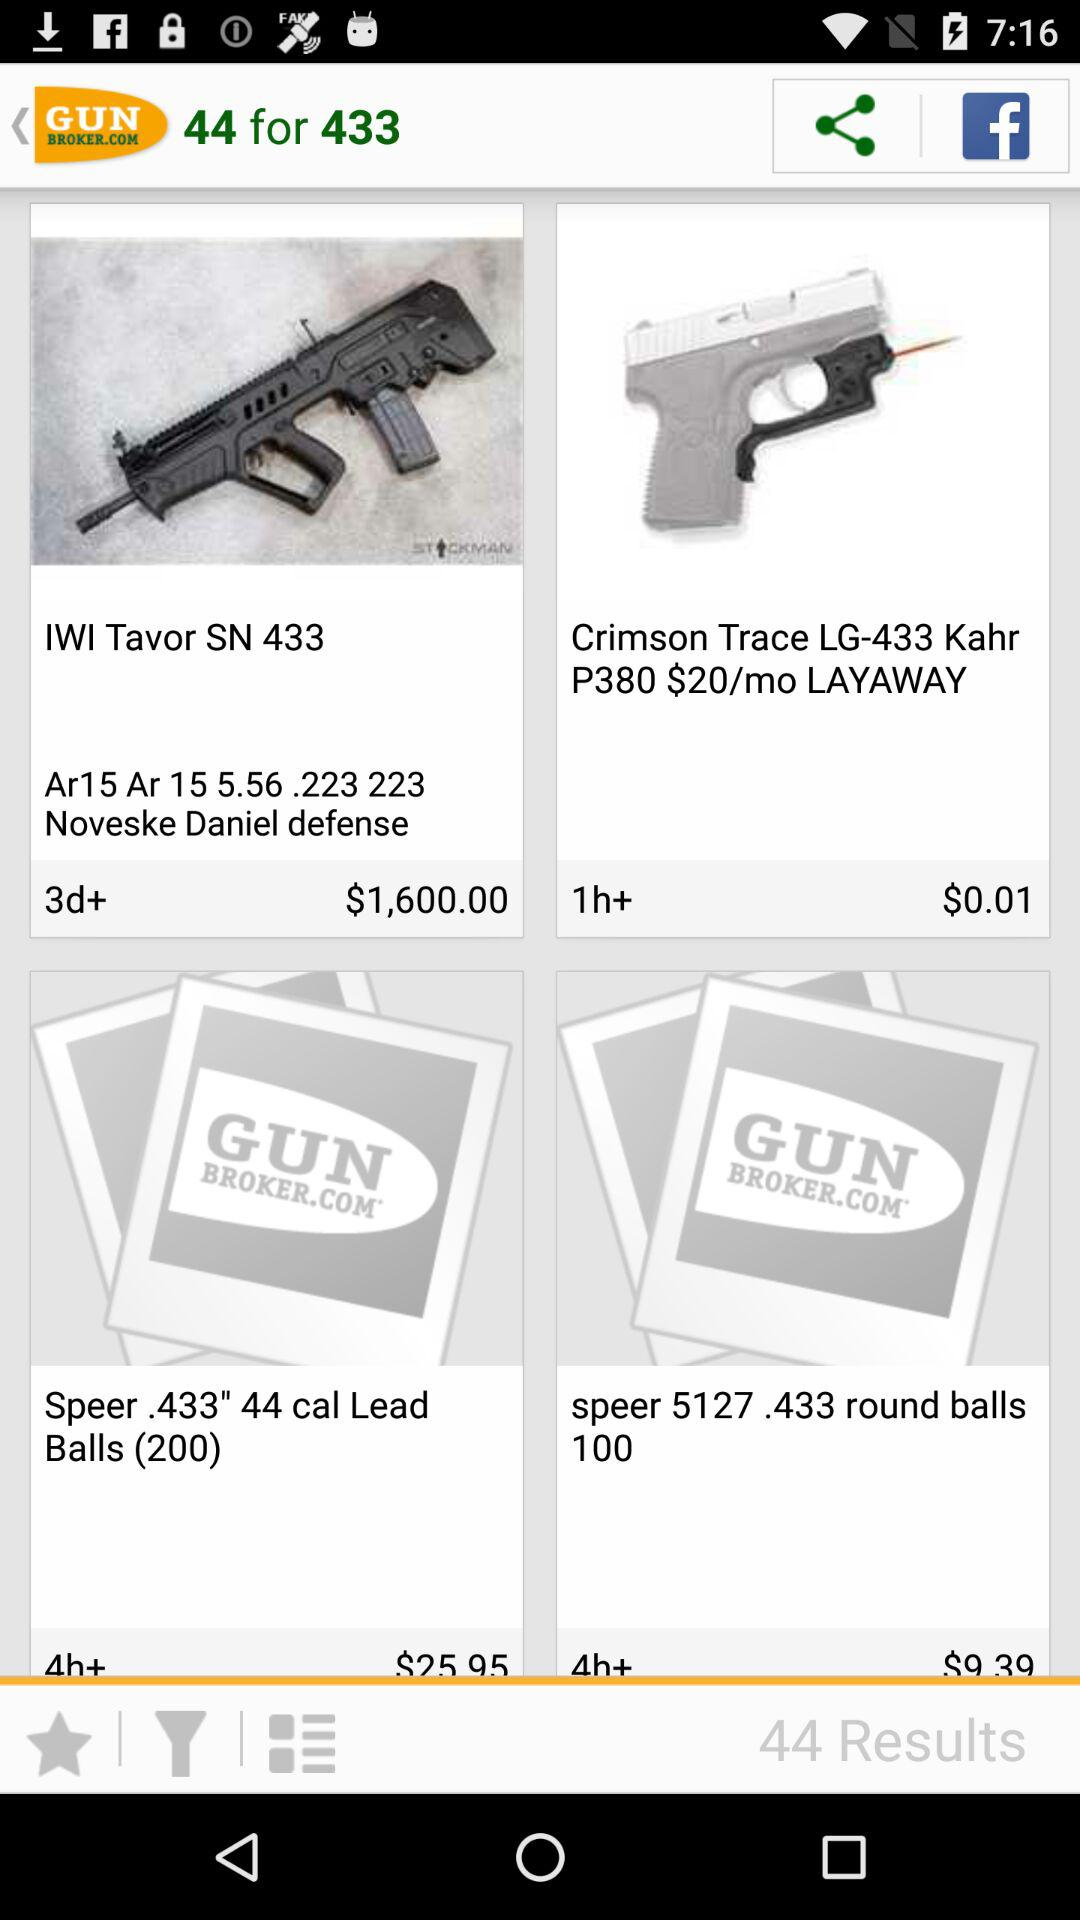What is the currency of price? The currency is dollars. 